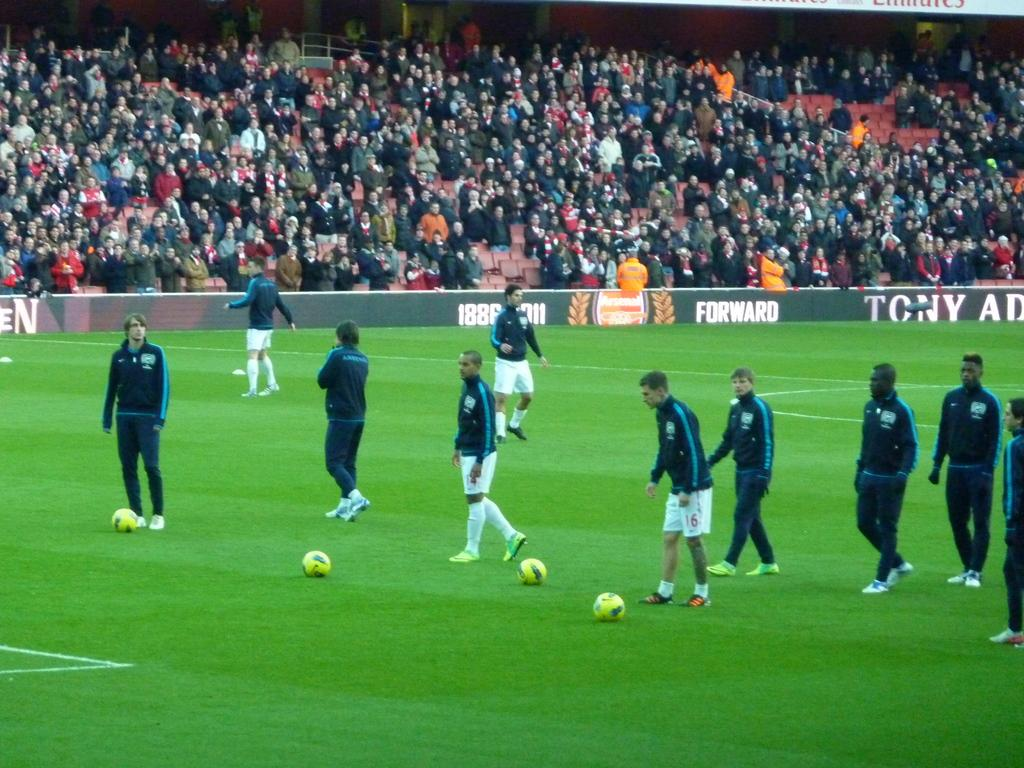What are the people on the ground in the image doing? There are players on the ground in the image, suggesting they are playing a game. What type of game might be depicted in the image? The presence of footballs in the image suggests that it is a football game. Who is watching the game in the image? There is an audience in the image, indicating that people are watching the game. What can be seen on the advertisement boards in the image? The advertisement boards have text and pictures in the image. Can you tell me how many snakes are slithering on the football field in the image? There are no snakes present in the image; it depicts a football game with players, footballs, and an audience. What type of medical advice can be found on the advertisement boards in the image? There is no doctor or medical advice present in the image; it features advertisement boards with text and pictures related to the game or sponsors. 